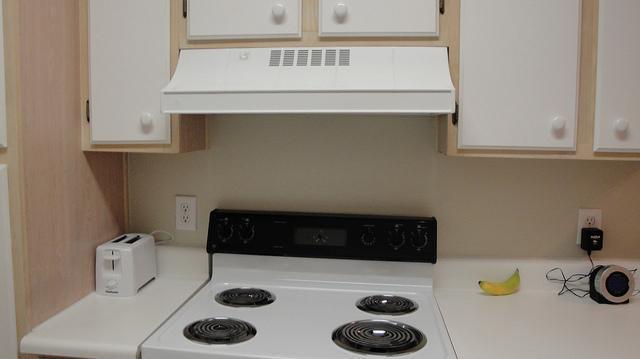How many burners are on the stove?
Give a very brief answer. 4. How many faces does this clock have?
Give a very brief answer. 0. 